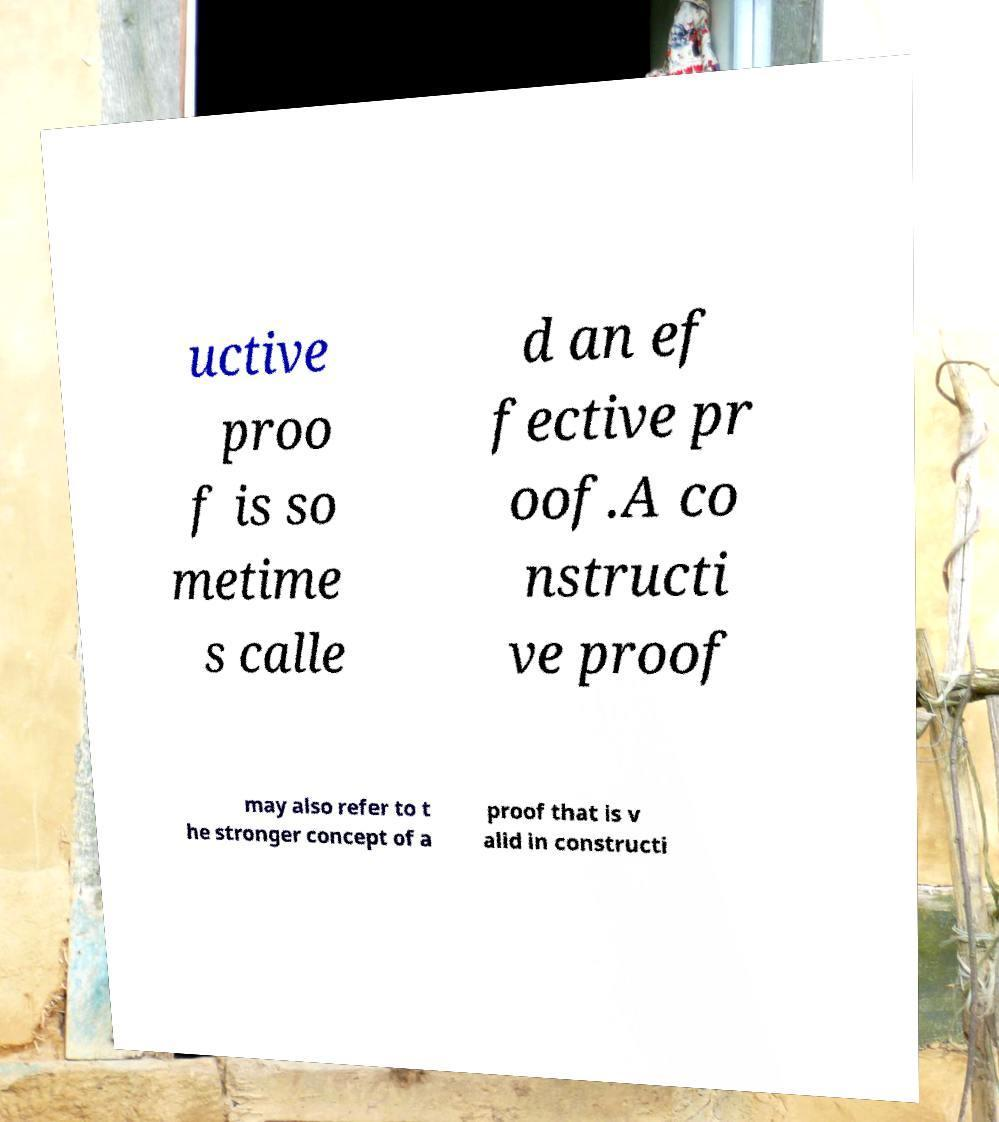I need the written content from this picture converted into text. Can you do that? uctive proo f is so metime s calle d an ef fective pr oof.A co nstructi ve proof may also refer to t he stronger concept of a proof that is v alid in constructi 